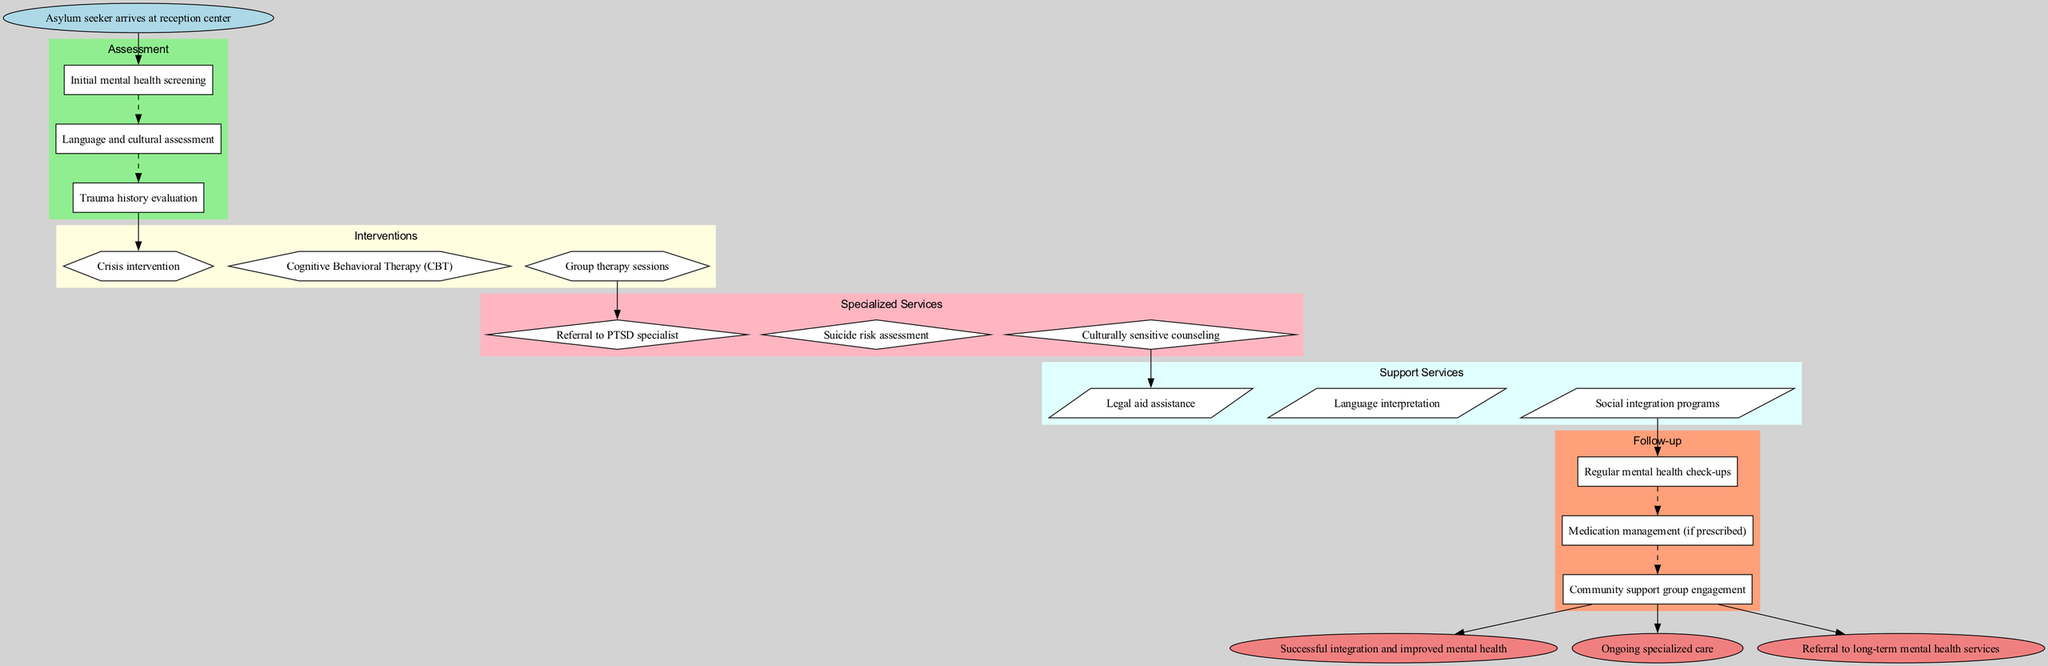What is the starting point of the clinical pathway? The starting point, as indicated in the diagram, is where the asylum seeker arrives at the reception center. This is typically the first step in the clinical pathway.
Answer: Asylum seeker arrives at reception center How many assessment steps are there in the pathway? The assessment steps are explicitly listed in the diagram, which shows three individual steps (initial mental health screening, language and cultural assessment, trauma history evaluation), leading to the conclusion that there are three assessment steps.
Answer: 3 Which intervention follows cognitive behavioral therapy? The diagram shows the interventions in a sequential order, where cognitive behavioral therapy (CBT) is the second intervention, followed by group therapy sessions listed after it, indicating that group therapy sessions directly follow CBT.
Answer: Group therapy sessions What type of service is culturally sensitive counseling classified under? Looking at the diagram, culturally sensitive counseling is categorized as a specialized service, which is indicated by the grouping and coloring of the node outlining specialized services.
Answer: Specialized Services What is the endpoint associated with ongoing specialized care? The endpoints listed in the diagram include various outcomes; one of the endpoints explicitly states "Ongoing specialized care", which relates directly to the question about what those specific endpoints are to the clinical pathway.
Answer: Ongoing specialized care How many follow-up steps are included in the pathway? By examining the follow-up section of the diagram, it is evident that there are three specific follow-up actions (regular mental health check-ups, medication management, community support group engagement), which totals to three follow-up steps.
Answer: 3 Which support service is indicated first in the diagram? The order in which support services are presented in the diagram shows that legal aid assistance is the first service mentioned, making it the initial service provided in that category.
Answer: Legal aid assistance Which specialized service follows the suicide risk assessment? In the specialized services section of the diagram, the first listed service is the suicide risk assessment, followed by culturally sensitive counseling. Therefore, culturally sensitive counseling follows the suicide risk assessment.
Answer: Culturally sensitive counseling 